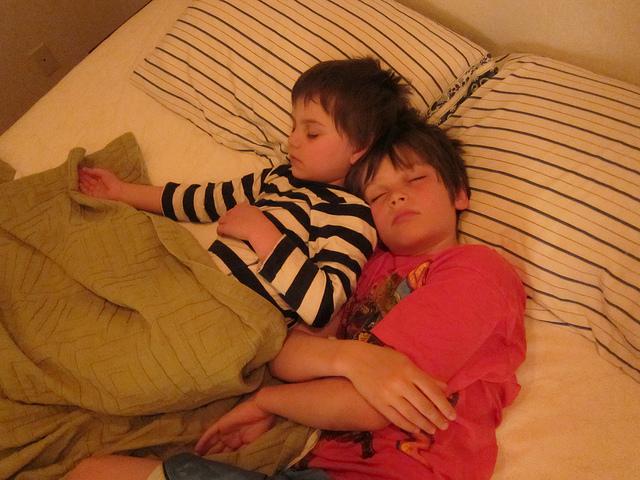How many people are awake?
Be succinct. 0. How many people are there?
Keep it brief. 2. Was this photo taken in a bedroom?
Write a very short answer. Yes. Are both kids covered?
Write a very short answer. No. 